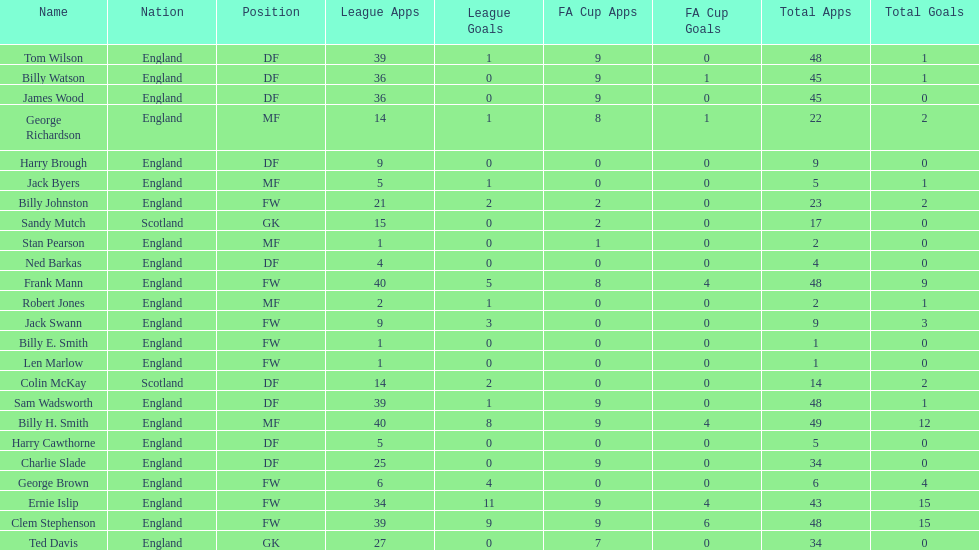How many players are fws? 8. 